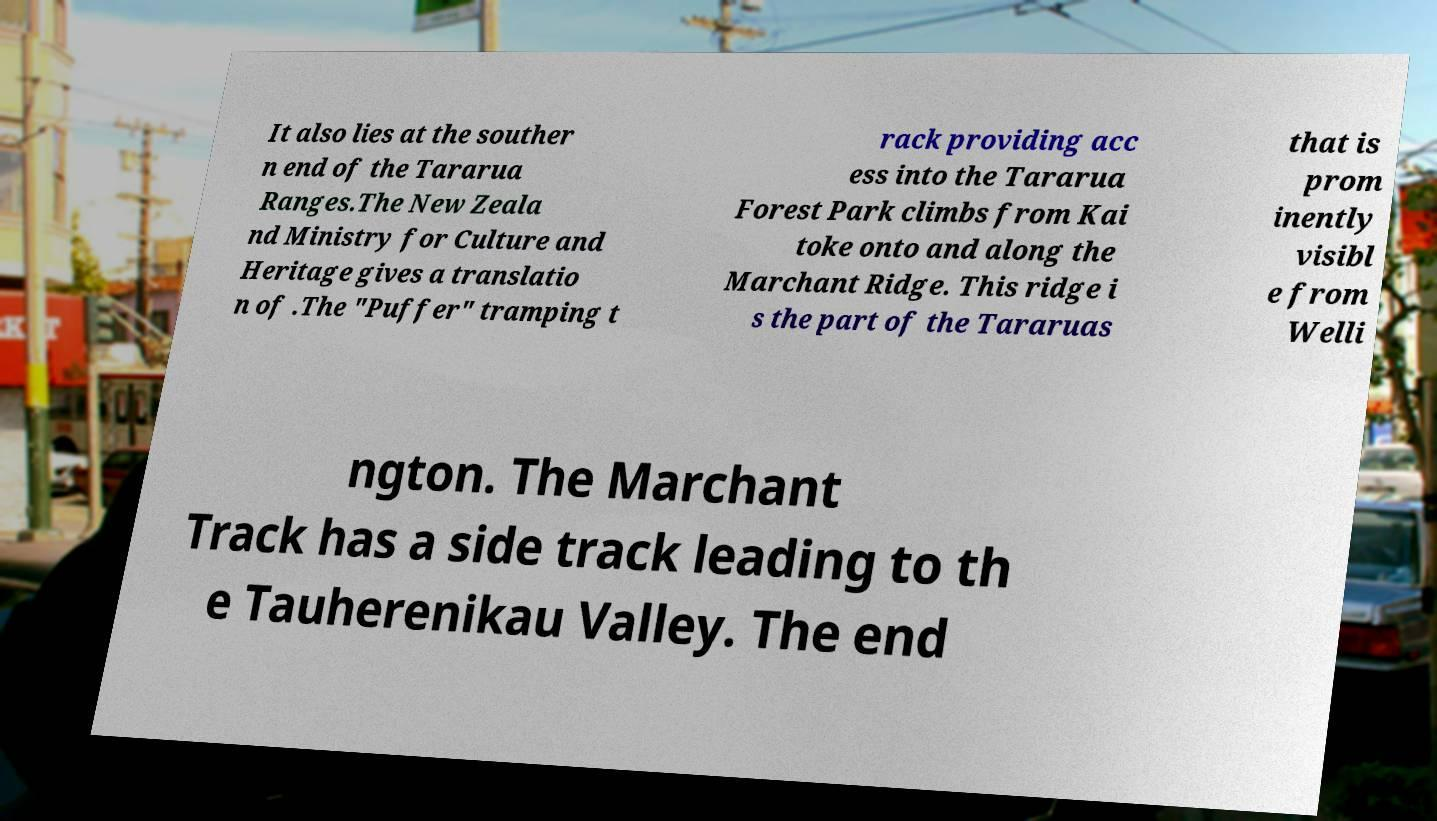Can you read and provide the text displayed in the image?This photo seems to have some interesting text. Can you extract and type it out for me? It also lies at the souther n end of the Tararua Ranges.The New Zeala nd Ministry for Culture and Heritage gives a translatio n of .The "Puffer" tramping t rack providing acc ess into the Tararua Forest Park climbs from Kai toke onto and along the Marchant Ridge. This ridge i s the part of the Tararuas that is prom inently visibl e from Welli ngton. The Marchant Track has a side track leading to th e Tauherenikau Valley. The end 